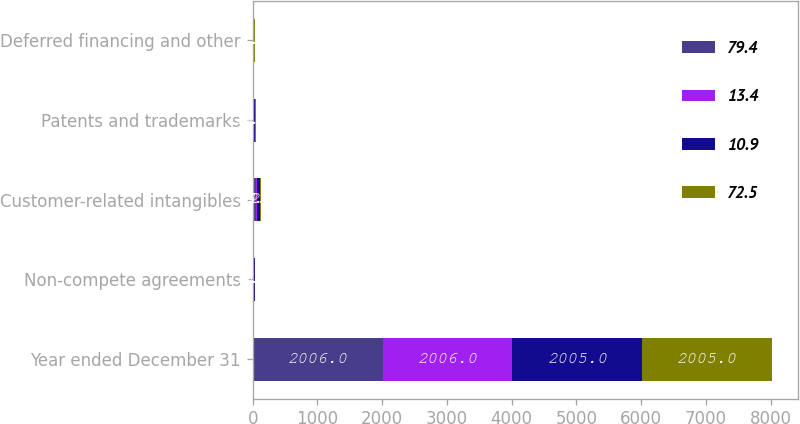<chart> <loc_0><loc_0><loc_500><loc_500><stacked_bar_chart><ecel><fcel>Year ended December 31<fcel>Non-compete agreements<fcel>Customer-related intangibles<fcel>Patents and trademarks<fcel>Deferred financing and other<nl><fcel>79.4<fcel>2006<fcel>15<fcel>45<fcel>6.1<fcel>6.4<nl><fcel>13.4<fcel>2006<fcel>9<fcel>14.7<fcel>20.1<fcel>7.2<nl><fcel>10.9<fcel>2005<fcel>9.6<fcel>52.7<fcel>9.3<fcel>7.8<nl><fcel>72.5<fcel>2005<fcel>7.6<fcel>12.1<fcel>11.3<fcel>7<nl></chart> 